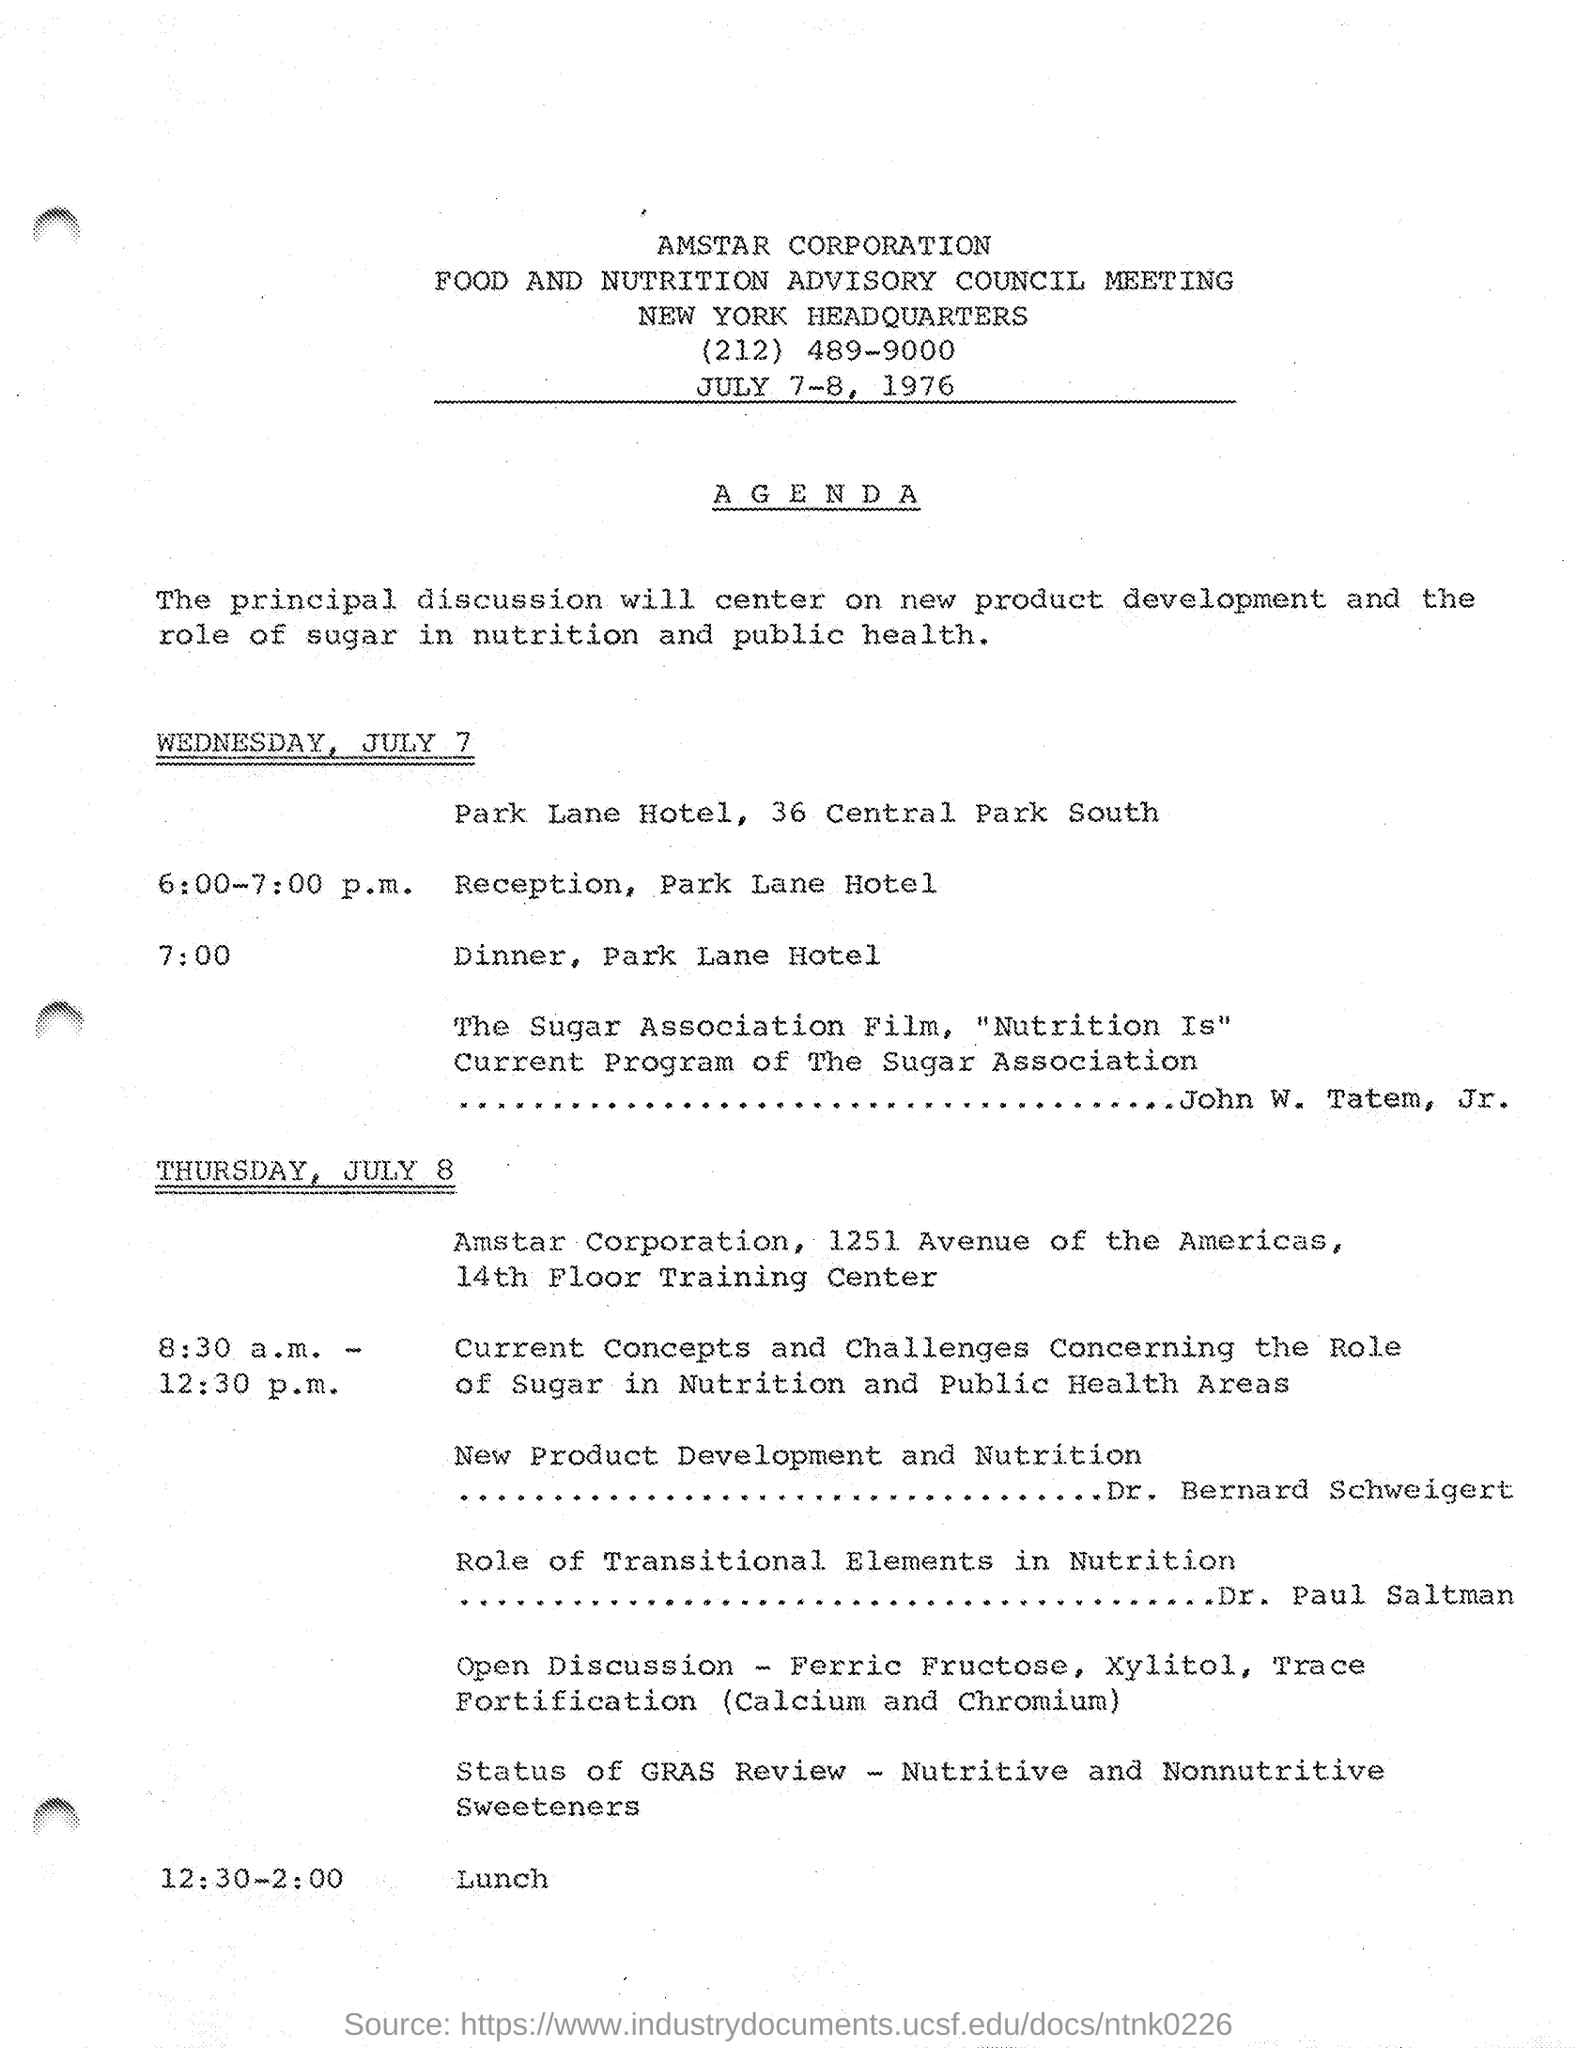Identify some key points in this picture. The location of the headquarter is New York, as mentioned on the given page. At 12:30-2:00 PM on July 8, the given schedule was as follows: lunch was taking place. The corporation mentioned in the given page is AMSTAR CORPORATION. On Wednesday, July 7, from 6:00-7:00 PM, there will be a program at the Park Lane Hotel, which includes a reception. The given schedule at 7:00 PM at the Park Lane Hotel is for dinner. 